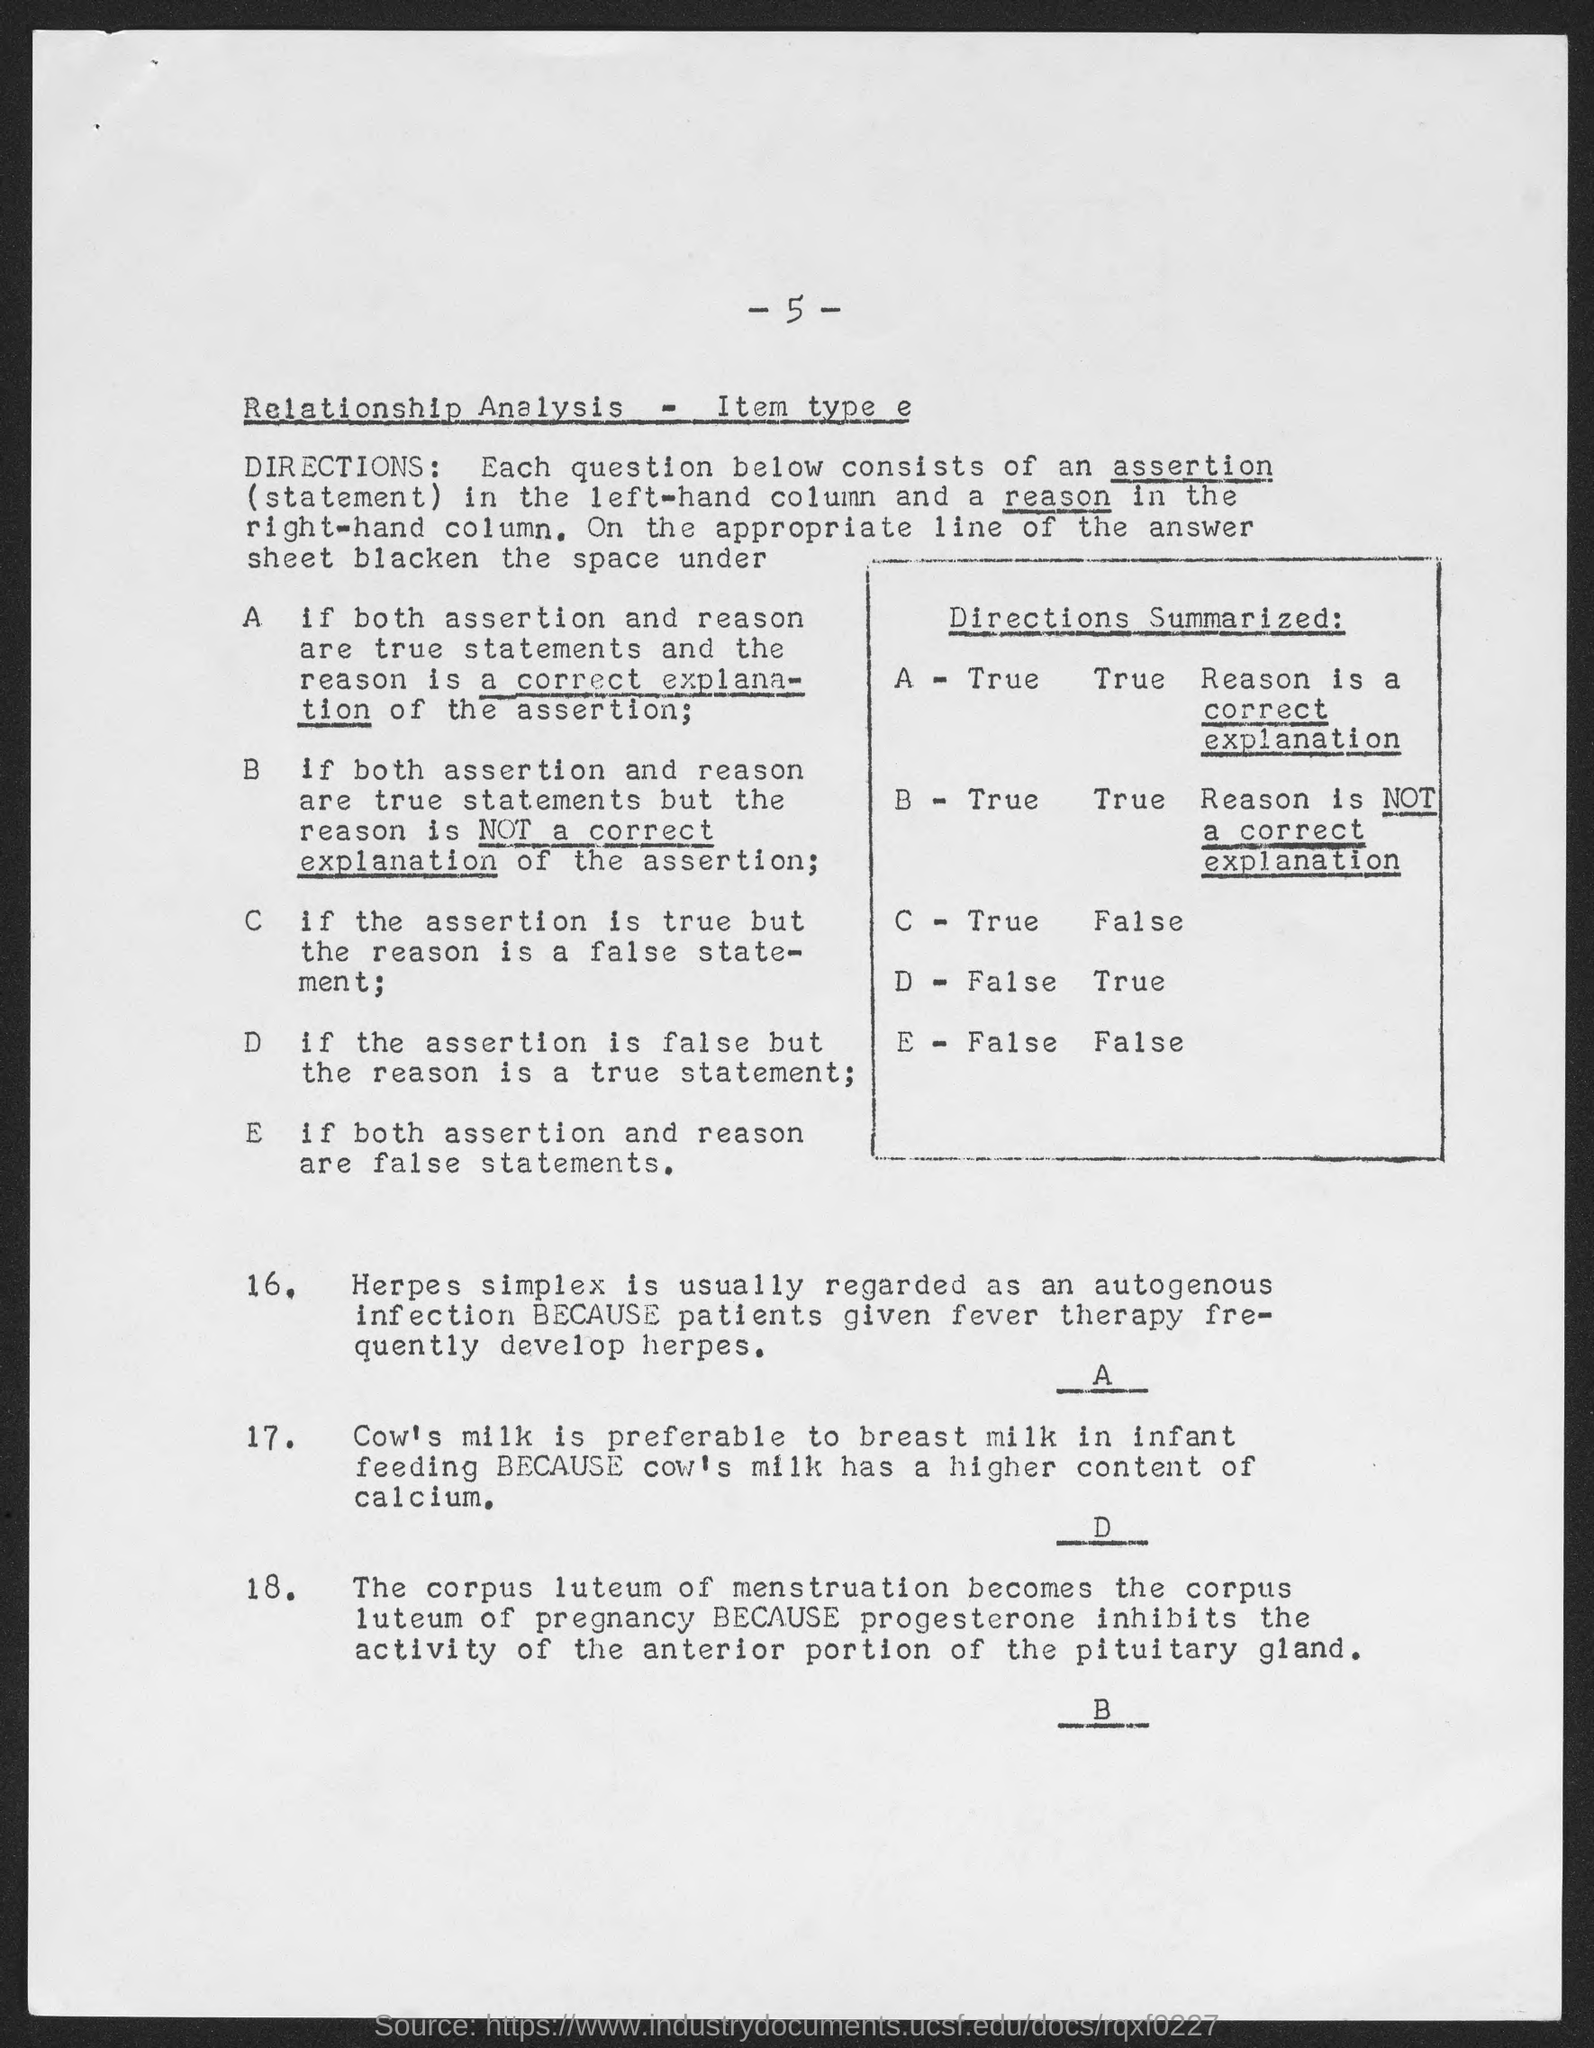What is the page number at top of the page?
Your answer should be compact. - 5 -. 